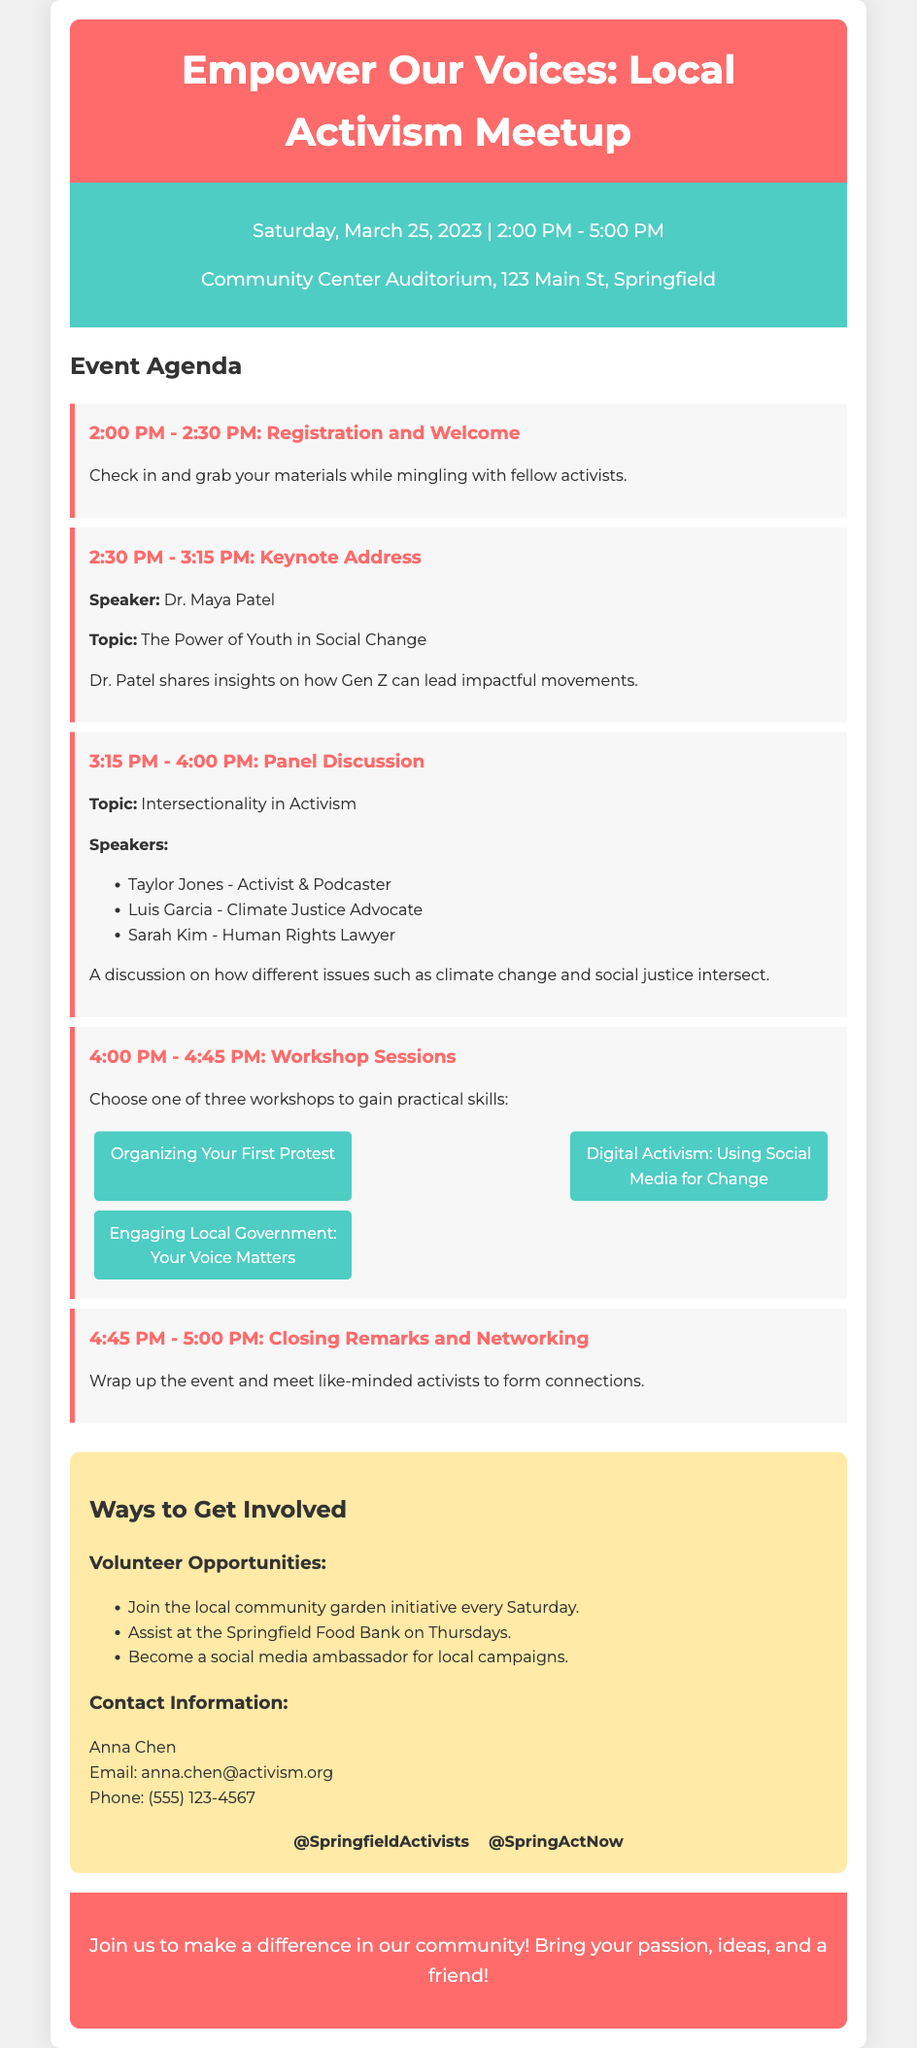What is the date of the meetup? The date of the meetup is clearly stated in the event details section of the document.
Answer: Saturday, March 25, 2023 Who is the keynote speaker? The name of the keynote speaker is mentioned in the agenda section along with her topic.
Answer: Dr. Maya Patel What time does the registration start? The registration start time is listed as part of the event agenda, specifically in the first agenda item.
Answer: 2:00 PM What is one of the workshop options available? The document lists three workshop options in the agenda, making it clear what attendees can choose from.
Answer: Digital Activism: Using Social Media for Change Which initiative can you volunteer for every Saturday? Volunteer opportunities are detailed in the get involved section, specifically listing activities and their schedules.
Answer: Community garden initiative What topic will be discussed in the panel? The panel discussion topic is explicitly mentioned in the agenda of the document, summarizing key discussion points.
Answer: Intersectionality in Activism What is the contact email for the event organizer? The contact information section provides the email of the point of contact for attendees who may have questions.
Answer: anna.chen@activism.org How many guests are participating in the panel discussion? The agenda lists the speakers participating in the panel discussion as well as their names.
Answer: Three 